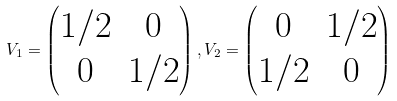<formula> <loc_0><loc_0><loc_500><loc_500>V _ { 1 } = \begin{pmatrix} 1 / 2 & 0 \\ 0 & 1 / 2 \end{pmatrix} , V _ { 2 } = \begin{pmatrix} 0 & 1 / 2 \\ 1 / 2 & 0 \end{pmatrix}</formula> 